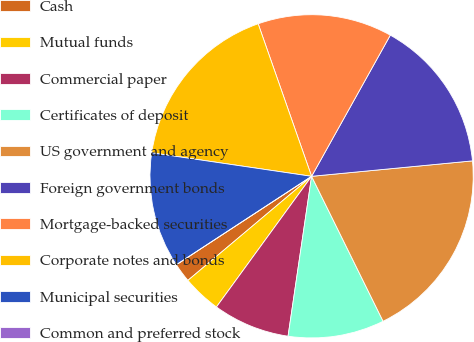Convert chart to OTSL. <chart><loc_0><loc_0><loc_500><loc_500><pie_chart><fcel>Cash<fcel>Mutual funds<fcel>Commercial paper<fcel>Certificates of deposit<fcel>US government and agency<fcel>Foreign government bonds<fcel>Mortgage-backed securities<fcel>Corporate notes and bonds<fcel>Municipal securities<fcel>Common and preferred stock<nl><fcel>1.92%<fcel>3.85%<fcel>7.69%<fcel>9.62%<fcel>19.23%<fcel>15.38%<fcel>13.46%<fcel>17.31%<fcel>11.54%<fcel>0.0%<nl></chart> 